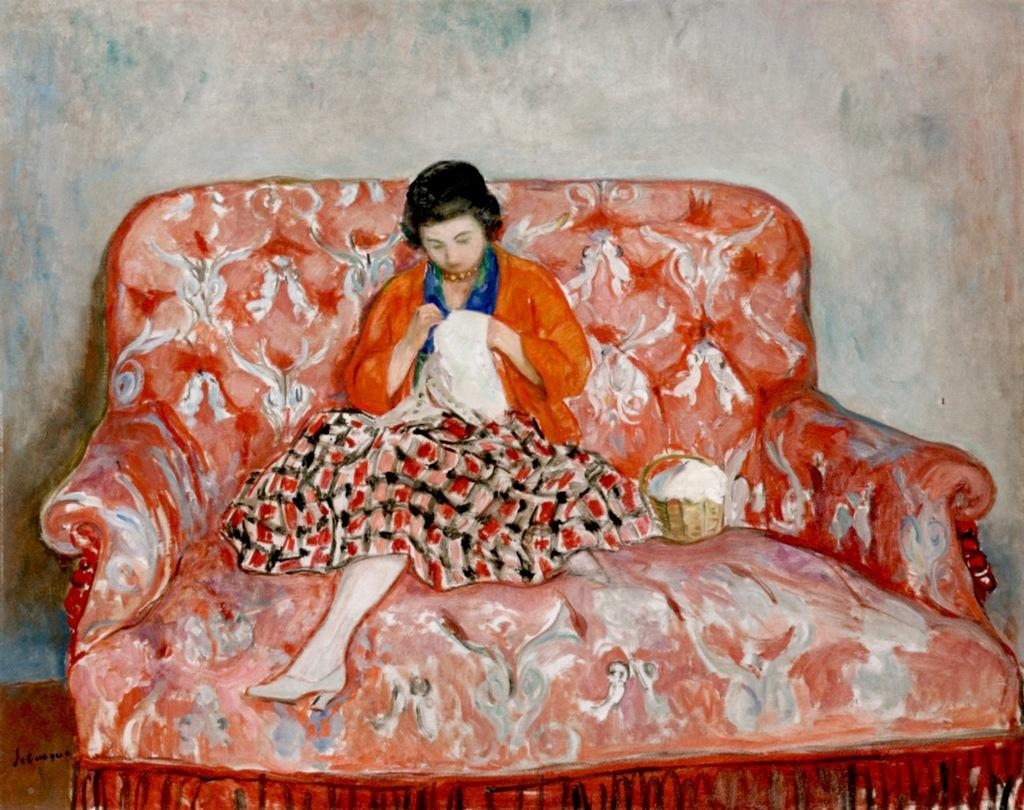What is the lady doing in the image? The lady is sitting on a sofa in the image. What object is beside the lady? There is a box beside the lady. What can be seen in the background of the image? There is a wall in the background of the image. What decision did the lady make while sitting on the sofa in the image? There is no information about any decision made by the lady in the image. 